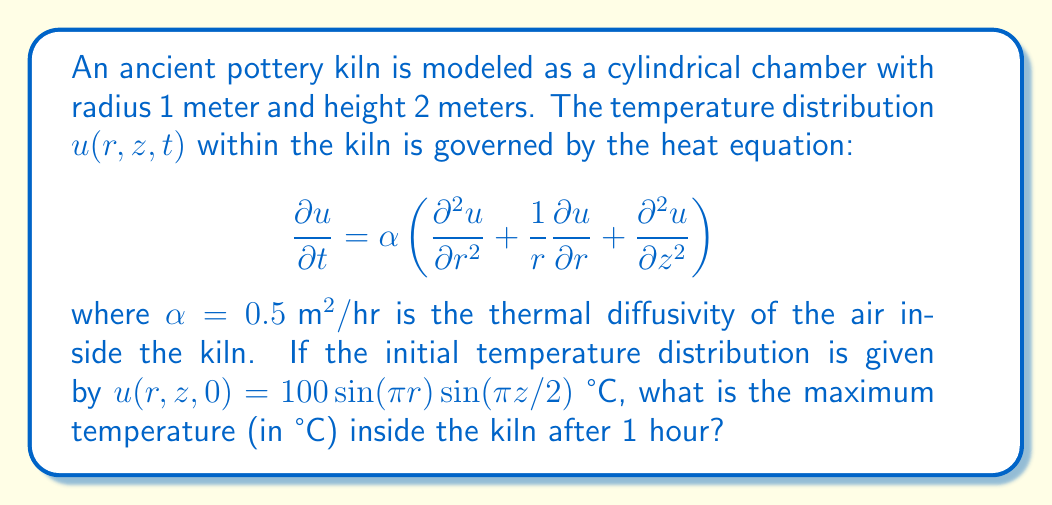Help me with this question. To solve this problem, we need to follow these steps:

1) The general solution to the heat equation in cylindrical coordinates is of the form:

   $$u(r,z,t) = \sum_{m,n} A_{mn} J_0(\lambda_m r) \sin(\frac{n\pi z}{L}) e^{-\alpha(\lambda_m^2 + (\frac{n\pi}{L})^2)t}$$

   where $J_0$ is the Bessel function of the first kind of order 0, $\lambda_m$ are the roots of $J_0$, and $L$ is the height of the cylinder.

2) Comparing with the initial condition, we see that only the first term ($m=1, n=1$) is non-zero:

   $$u(r,z,0) = A_{11} J_0(\lambda_1 r) \sin(\frac{\pi z}{2}) = 100\sin(\pi r)\sin(\frac{\pi z}{2})$$

3) This implies $\lambda_1 = \pi$ and $A_{11} = 100$.

4) Therefore, the solution is:

   $$u(r,z,t) = 100 J_0(\pi r) \sin(\frac{\pi z}{2}) e^{-\alpha(\pi^2 + (\frac{\pi}{2})^2)t}$$

5) After 1 hour (t = 1), this becomes:

   $$u(r,z,1) = 100 J_0(\pi r) \sin(\frac{\pi z}{2}) e^{-0.5(\pi^2 + (\frac{\pi}{2})^2)}$$

6) The maximum value of $J_0(\pi r)$ is 1 (at r = 0), and the maximum value of $\sin(\frac{\pi z}{2})$ is 1 (at z = 1).

7) Therefore, the maximum temperature after 1 hour is:

   $$u_{max} = 100 \cdot e^{-0.5(\pi^2 + (\frac{\pi}{2})^2)} \approx 4.54 \text{ °C}$$
Answer: 4.54 °C 